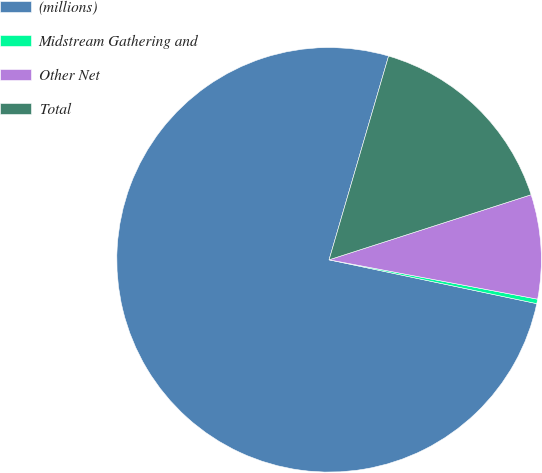Convert chart. <chart><loc_0><loc_0><loc_500><loc_500><pie_chart><fcel>(millions)<fcel>Midstream Gathering and<fcel>Other Net<fcel>Total<nl><fcel>76.22%<fcel>0.34%<fcel>7.93%<fcel>15.52%<nl></chart> 